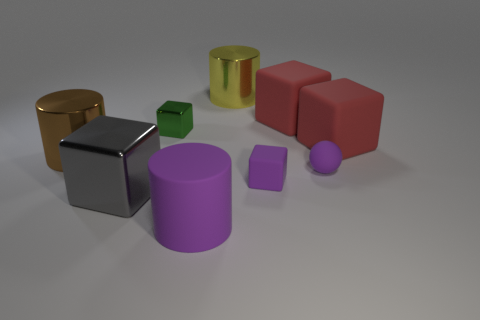What number of other objects are the same size as the gray shiny block?
Your answer should be compact. 5. There is a large gray shiny thing; how many tiny metallic cubes are right of it?
Offer a terse response. 1. What size is the brown object?
Ensure brevity in your answer.  Large. Are the red block right of the purple rubber sphere and the small cube that is in front of the small matte sphere made of the same material?
Provide a short and direct response. Yes. Is there a big cylinder of the same color as the tiny ball?
Offer a terse response. Yes. There is another cube that is the same size as the green metallic block; what is its color?
Provide a short and direct response. Purple. Do the thing that is in front of the gray shiny cube and the tiny metal object have the same color?
Provide a succinct answer. No. Is there a purple sphere made of the same material as the purple cylinder?
Your response must be concise. Yes. There is a big matte object that is the same color as the tiny matte sphere; what is its shape?
Offer a very short reply. Cylinder. Is the number of large red matte cubes in front of the gray shiny object less than the number of yellow things?
Offer a very short reply. Yes. 